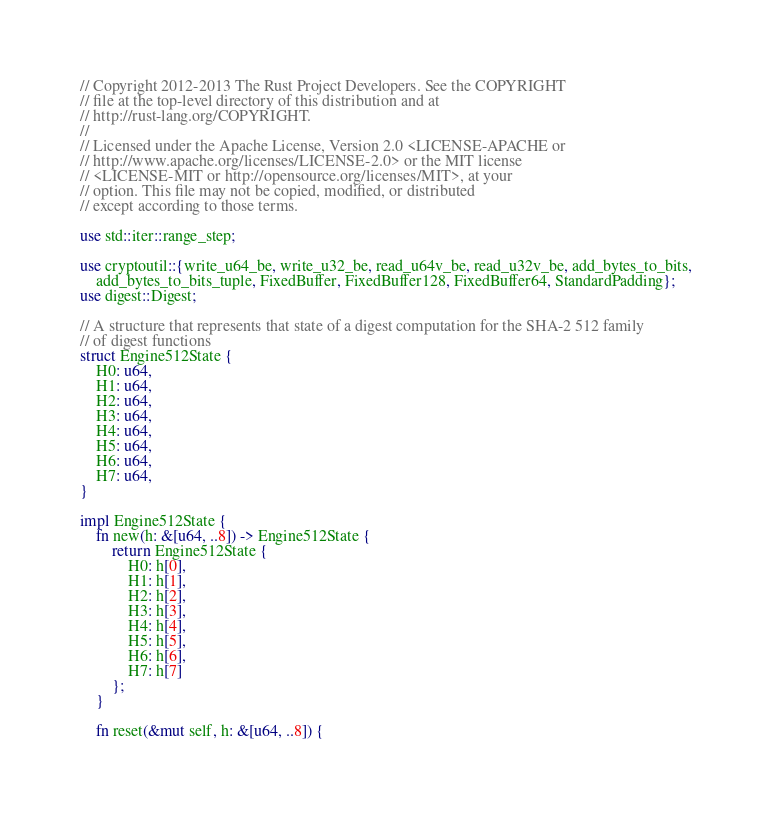<code> <loc_0><loc_0><loc_500><loc_500><_Rust_>// Copyright 2012-2013 The Rust Project Developers. See the COPYRIGHT
// file at the top-level directory of this distribution and at
// http://rust-lang.org/COPYRIGHT.
//
// Licensed under the Apache License, Version 2.0 <LICENSE-APACHE or
// http://www.apache.org/licenses/LICENSE-2.0> or the MIT license
// <LICENSE-MIT or http://opensource.org/licenses/MIT>, at your
// option. This file may not be copied, modified, or distributed
// except according to those terms.

use std::iter::range_step;

use cryptoutil::{write_u64_be, write_u32_be, read_u64v_be, read_u32v_be, add_bytes_to_bits,
    add_bytes_to_bits_tuple, FixedBuffer, FixedBuffer128, FixedBuffer64, StandardPadding};
use digest::Digest;

// A structure that represents that state of a digest computation for the SHA-2 512 family
// of digest functions
struct Engine512State {
    H0: u64,
    H1: u64,
    H2: u64,
    H3: u64,
    H4: u64,
    H5: u64,
    H6: u64,
    H7: u64,
}

impl Engine512State {
    fn new(h: &[u64, ..8]) -> Engine512State {
        return Engine512State {
            H0: h[0],
            H1: h[1],
            H2: h[2],
            H3: h[3],
            H4: h[4],
            H5: h[5],
            H6: h[6],
            H7: h[7]
        };
    }

    fn reset(&mut self, h: &[u64, ..8]) {</code> 